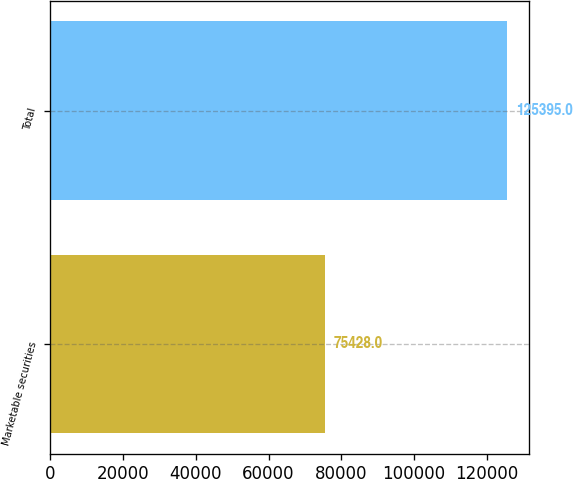<chart> <loc_0><loc_0><loc_500><loc_500><bar_chart><fcel>Marketable securities<fcel>Total<nl><fcel>75428<fcel>125395<nl></chart> 